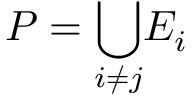<formula> <loc_0><loc_0><loc_500><loc_500>P = \underset { i \neq j } { \bigcup } E _ { i }</formula> 